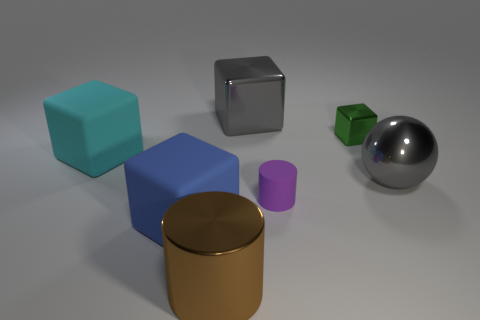Do the small block and the big cube to the right of the large brown cylinder have the same material?
Keep it short and to the point. Yes. The cylinder that is right of the big shiny object in front of the large rubber thing in front of the purple object is what color?
Your answer should be very brief. Purple. Are there any other things that have the same size as the gray ball?
Ensure brevity in your answer.  Yes. There is a big cylinder; does it have the same color as the cylinder that is behind the big cylinder?
Make the answer very short. No. What is the color of the big metal sphere?
Make the answer very short. Gray. What is the shape of the thing that is in front of the matte object in front of the small object in front of the large cyan rubber block?
Keep it short and to the point. Cylinder. What number of other things are the same color as the big sphere?
Provide a succinct answer. 1. Is the number of blue blocks behind the small shiny thing greater than the number of tiny shiny objects behind the cyan object?
Your answer should be compact. No. Are there any metallic objects in front of the blue object?
Provide a short and direct response. Yes. What is the large object that is both right of the metallic cylinder and to the left of the gray metallic ball made of?
Your answer should be very brief. Metal. 